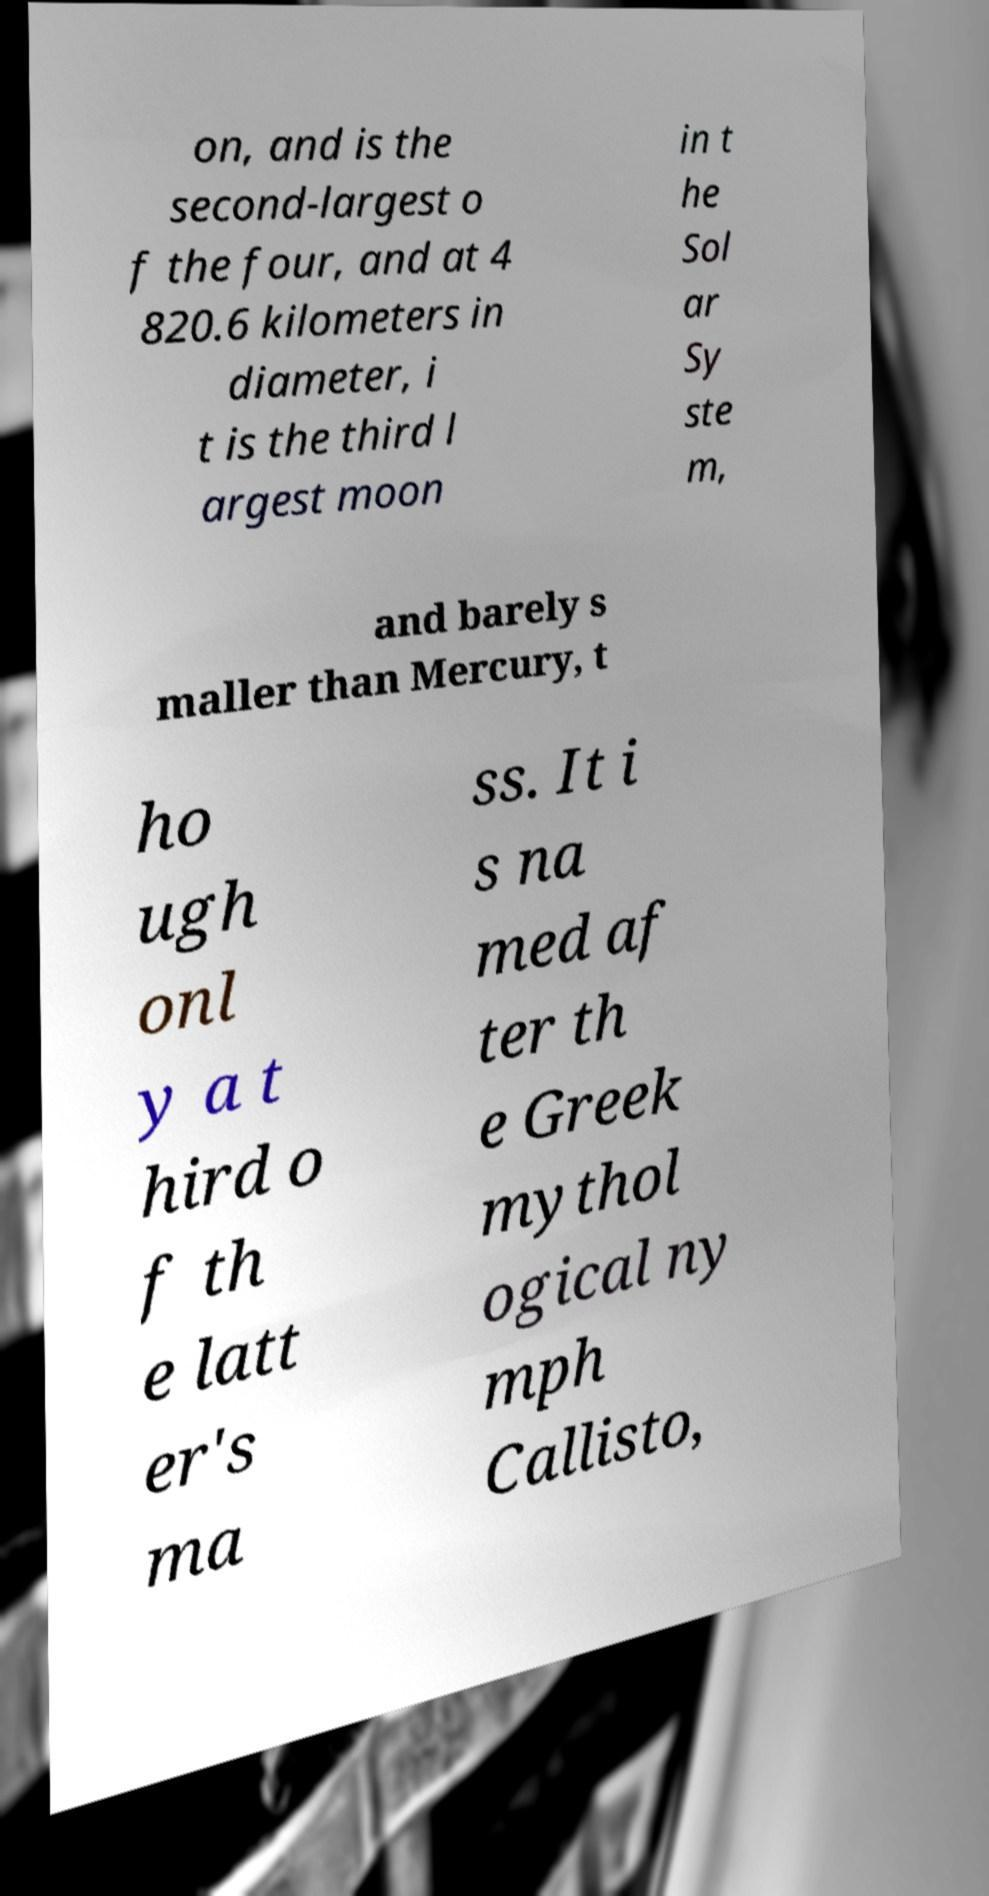Can you accurately transcribe the text from the provided image for me? on, and is the second-largest o f the four, and at 4 820.6 kilometers in diameter, i t is the third l argest moon in t he Sol ar Sy ste m, and barely s maller than Mercury, t ho ugh onl y a t hird o f th e latt er's ma ss. It i s na med af ter th e Greek mythol ogical ny mph Callisto, 